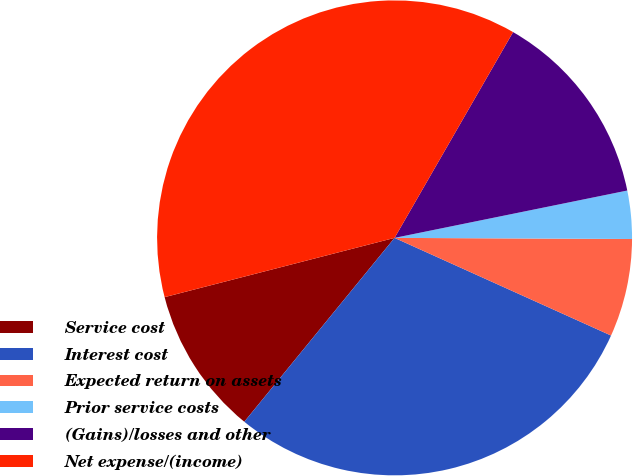Convert chart. <chart><loc_0><loc_0><loc_500><loc_500><pie_chart><fcel>Service cost<fcel>Interest cost<fcel>Expected return on assets<fcel>Prior service costs<fcel>(Gains)/losses and other<fcel>Net expense/(income)<nl><fcel>10.08%<fcel>29.16%<fcel>6.67%<fcel>3.27%<fcel>13.49%<fcel>37.33%<nl></chart> 